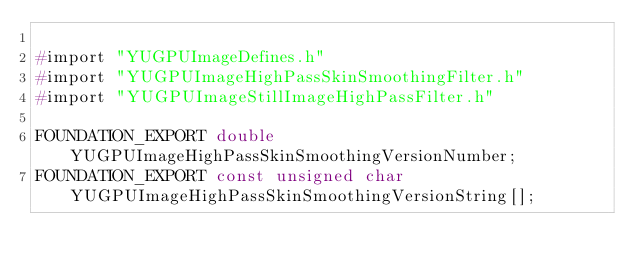Convert code to text. <code><loc_0><loc_0><loc_500><loc_500><_C_>
#import "YUGPUImageDefines.h"
#import "YUGPUImageHighPassSkinSmoothingFilter.h"
#import "YUGPUImageStillImageHighPassFilter.h"

FOUNDATION_EXPORT double YUGPUImageHighPassSkinSmoothingVersionNumber;
FOUNDATION_EXPORT const unsigned char YUGPUImageHighPassSkinSmoothingVersionString[];

</code> 